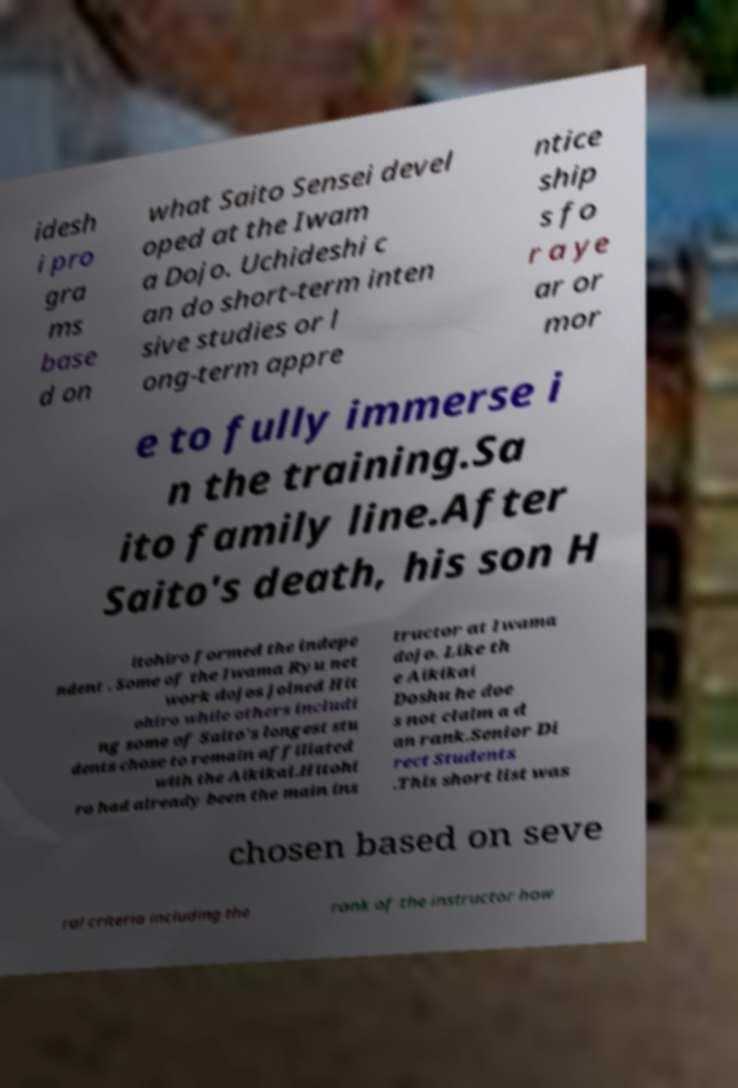Can you accurately transcribe the text from the provided image for me? idesh i pro gra ms base d on what Saito Sensei devel oped at the Iwam a Dojo. Uchideshi c an do short-term inten sive studies or l ong-term appre ntice ship s fo r a ye ar or mor e to fully immerse i n the training.Sa ito family line.After Saito's death, his son H itohiro formed the indepe ndent . Some of the Iwama Ryu net work dojos joined Hit ohiro while others includi ng some of Saito's longest stu dents chose to remain affiliated with the Aikikai.Hitohi ro had already been the main ins tructor at Iwama dojo. Like th e Aikikai Doshu he doe s not claim a d an rank.Senior Di rect Students .This short list was chosen based on seve ral criteria including the rank of the instructor how 